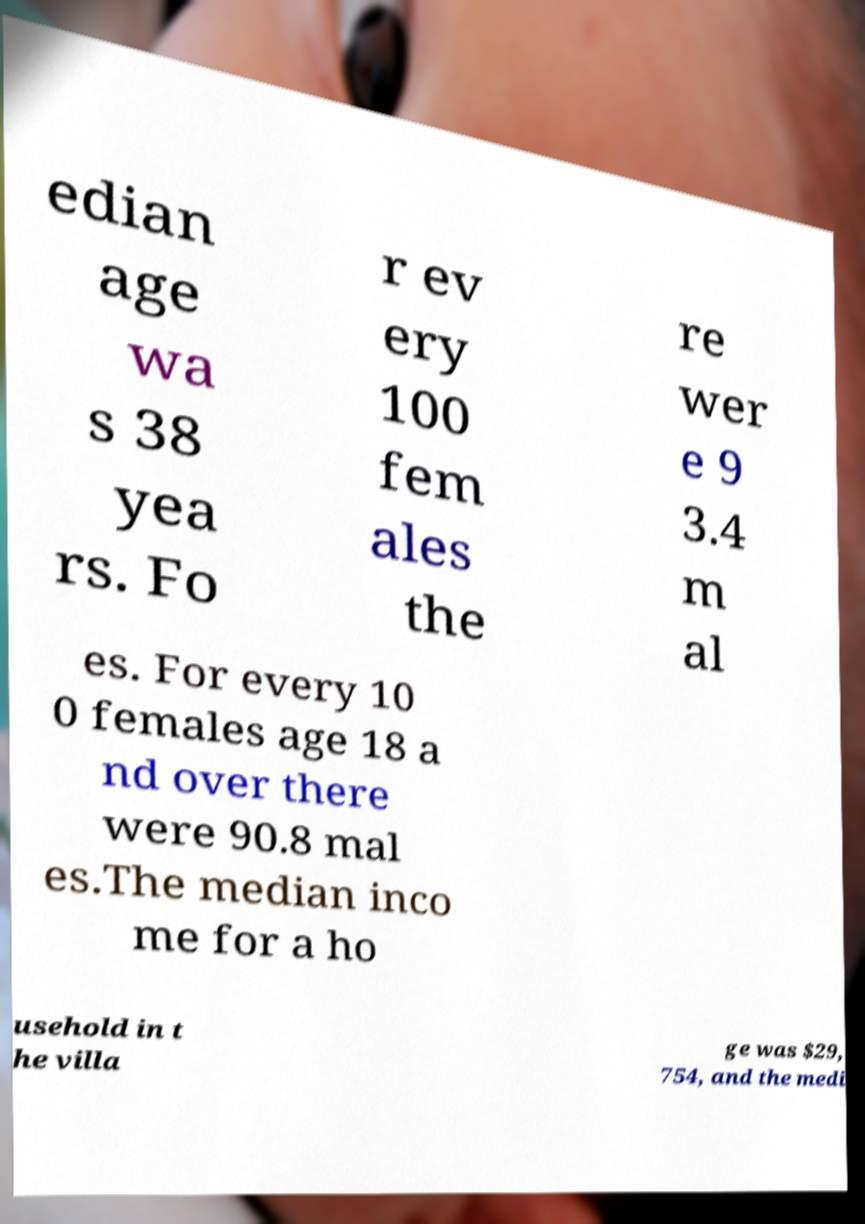Please read and relay the text visible in this image. What does it say? edian age wa s 38 yea rs. Fo r ev ery 100 fem ales the re wer e 9 3.4 m al es. For every 10 0 females age 18 a nd over there were 90.8 mal es.The median inco me for a ho usehold in t he villa ge was $29, 754, and the medi 